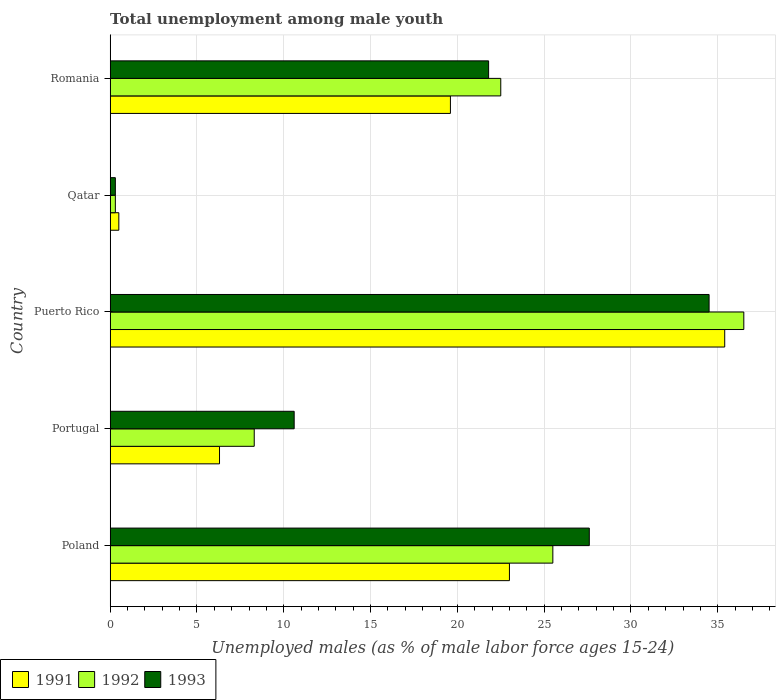How many different coloured bars are there?
Keep it short and to the point. 3. How many groups of bars are there?
Your answer should be compact. 5. Are the number of bars on each tick of the Y-axis equal?
Provide a short and direct response. Yes. What is the label of the 3rd group of bars from the top?
Your answer should be compact. Puerto Rico. In how many cases, is the number of bars for a given country not equal to the number of legend labels?
Make the answer very short. 0. What is the percentage of unemployed males in in 1991 in Puerto Rico?
Make the answer very short. 35.4. Across all countries, what is the maximum percentage of unemployed males in in 1992?
Make the answer very short. 36.5. Across all countries, what is the minimum percentage of unemployed males in in 1993?
Give a very brief answer. 0.3. In which country was the percentage of unemployed males in in 1993 maximum?
Offer a very short reply. Puerto Rico. In which country was the percentage of unemployed males in in 1992 minimum?
Provide a short and direct response. Qatar. What is the total percentage of unemployed males in in 1992 in the graph?
Offer a very short reply. 93.1. What is the difference between the percentage of unemployed males in in 1993 in Portugal and that in Puerto Rico?
Offer a terse response. -23.9. What is the difference between the percentage of unemployed males in in 1992 in Puerto Rico and the percentage of unemployed males in in 1991 in Portugal?
Your answer should be very brief. 30.2. What is the average percentage of unemployed males in in 1992 per country?
Offer a terse response. 18.62. What is the difference between the percentage of unemployed males in in 1993 and percentage of unemployed males in in 1992 in Poland?
Keep it short and to the point. 2.1. What is the ratio of the percentage of unemployed males in in 1993 in Puerto Rico to that in Qatar?
Give a very brief answer. 115. Is the percentage of unemployed males in in 1993 in Portugal less than that in Puerto Rico?
Provide a succinct answer. Yes. What is the difference between the highest and the second highest percentage of unemployed males in in 1991?
Ensure brevity in your answer.  12.4. What is the difference between the highest and the lowest percentage of unemployed males in in 1993?
Your response must be concise. 34.2. What does the 3rd bar from the top in Qatar represents?
Give a very brief answer. 1991. Is it the case that in every country, the sum of the percentage of unemployed males in in 1993 and percentage of unemployed males in in 1991 is greater than the percentage of unemployed males in in 1992?
Your response must be concise. Yes. Are all the bars in the graph horizontal?
Make the answer very short. Yes. What is the difference between two consecutive major ticks on the X-axis?
Offer a very short reply. 5. Are the values on the major ticks of X-axis written in scientific E-notation?
Your response must be concise. No. What is the title of the graph?
Give a very brief answer. Total unemployment among male youth. What is the label or title of the X-axis?
Ensure brevity in your answer.  Unemployed males (as % of male labor force ages 15-24). What is the Unemployed males (as % of male labor force ages 15-24) in 1991 in Poland?
Your answer should be very brief. 23. What is the Unemployed males (as % of male labor force ages 15-24) of 1992 in Poland?
Offer a very short reply. 25.5. What is the Unemployed males (as % of male labor force ages 15-24) in 1993 in Poland?
Provide a succinct answer. 27.6. What is the Unemployed males (as % of male labor force ages 15-24) of 1991 in Portugal?
Make the answer very short. 6.3. What is the Unemployed males (as % of male labor force ages 15-24) of 1992 in Portugal?
Give a very brief answer. 8.3. What is the Unemployed males (as % of male labor force ages 15-24) of 1993 in Portugal?
Your answer should be very brief. 10.6. What is the Unemployed males (as % of male labor force ages 15-24) in 1991 in Puerto Rico?
Offer a terse response. 35.4. What is the Unemployed males (as % of male labor force ages 15-24) in 1992 in Puerto Rico?
Offer a terse response. 36.5. What is the Unemployed males (as % of male labor force ages 15-24) in 1993 in Puerto Rico?
Give a very brief answer. 34.5. What is the Unemployed males (as % of male labor force ages 15-24) of 1991 in Qatar?
Provide a succinct answer. 0.5. What is the Unemployed males (as % of male labor force ages 15-24) of 1992 in Qatar?
Provide a succinct answer. 0.3. What is the Unemployed males (as % of male labor force ages 15-24) in 1993 in Qatar?
Provide a succinct answer. 0.3. What is the Unemployed males (as % of male labor force ages 15-24) in 1991 in Romania?
Make the answer very short. 19.6. What is the Unemployed males (as % of male labor force ages 15-24) in 1993 in Romania?
Provide a short and direct response. 21.8. Across all countries, what is the maximum Unemployed males (as % of male labor force ages 15-24) in 1991?
Your answer should be very brief. 35.4. Across all countries, what is the maximum Unemployed males (as % of male labor force ages 15-24) in 1992?
Offer a terse response. 36.5. Across all countries, what is the maximum Unemployed males (as % of male labor force ages 15-24) of 1993?
Your answer should be compact. 34.5. Across all countries, what is the minimum Unemployed males (as % of male labor force ages 15-24) of 1992?
Give a very brief answer. 0.3. Across all countries, what is the minimum Unemployed males (as % of male labor force ages 15-24) of 1993?
Offer a terse response. 0.3. What is the total Unemployed males (as % of male labor force ages 15-24) of 1991 in the graph?
Make the answer very short. 84.8. What is the total Unemployed males (as % of male labor force ages 15-24) in 1992 in the graph?
Provide a succinct answer. 93.1. What is the total Unemployed males (as % of male labor force ages 15-24) in 1993 in the graph?
Your answer should be very brief. 94.8. What is the difference between the Unemployed males (as % of male labor force ages 15-24) in 1991 in Poland and that in Portugal?
Give a very brief answer. 16.7. What is the difference between the Unemployed males (as % of male labor force ages 15-24) in 1993 in Poland and that in Portugal?
Your answer should be compact. 17. What is the difference between the Unemployed males (as % of male labor force ages 15-24) in 1991 in Poland and that in Puerto Rico?
Provide a succinct answer. -12.4. What is the difference between the Unemployed males (as % of male labor force ages 15-24) of 1993 in Poland and that in Puerto Rico?
Offer a terse response. -6.9. What is the difference between the Unemployed males (as % of male labor force ages 15-24) of 1991 in Poland and that in Qatar?
Your response must be concise. 22.5. What is the difference between the Unemployed males (as % of male labor force ages 15-24) of 1992 in Poland and that in Qatar?
Your response must be concise. 25.2. What is the difference between the Unemployed males (as % of male labor force ages 15-24) in 1993 in Poland and that in Qatar?
Your response must be concise. 27.3. What is the difference between the Unemployed males (as % of male labor force ages 15-24) in 1991 in Poland and that in Romania?
Your answer should be compact. 3.4. What is the difference between the Unemployed males (as % of male labor force ages 15-24) of 1992 in Poland and that in Romania?
Ensure brevity in your answer.  3. What is the difference between the Unemployed males (as % of male labor force ages 15-24) of 1991 in Portugal and that in Puerto Rico?
Ensure brevity in your answer.  -29.1. What is the difference between the Unemployed males (as % of male labor force ages 15-24) in 1992 in Portugal and that in Puerto Rico?
Ensure brevity in your answer.  -28.2. What is the difference between the Unemployed males (as % of male labor force ages 15-24) of 1993 in Portugal and that in Puerto Rico?
Give a very brief answer. -23.9. What is the difference between the Unemployed males (as % of male labor force ages 15-24) in 1991 in Portugal and that in Qatar?
Keep it short and to the point. 5.8. What is the difference between the Unemployed males (as % of male labor force ages 15-24) of 1993 in Portugal and that in Qatar?
Provide a succinct answer. 10.3. What is the difference between the Unemployed males (as % of male labor force ages 15-24) in 1991 in Portugal and that in Romania?
Your response must be concise. -13.3. What is the difference between the Unemployed males (as % of male labor force ages 15-24) of 1992 in Portugal and that in Romania?
Keep it short and to the point. -14.2. What is the difference between the Unemployed males (as % of male labor force ages 15-24) in 1993 in Portugal and that in Romania?
Your answer should be very brief. -11.2. What is the difference between the Unemployed males (as % of male labor force ages 15-24) of 1991 in Puerto Rico and that in Qatar?
Your answer should be compact. 34.9. What is the difference between the Unemployed males (as % of male labor force ages 15-24) of 1992 in Puerto Rico and that in Qatar?
Your answer should be compact. 36.2. What is the difference between the Unemployed males (as % of male labor force ages 15-24) of 1993 in Puerto Rico and that in Qatar?
Your answer should be very brief. 34.2. What is the difference between the Unemployed males (as % of male labor force ages 15-24) of 1991 in Qatar and that in Romania?
Ensure brevity in your answer.  -19.1. What is the difference between the Unemployed males (as % of male labor force ages 15-24) of 1992 in Qatar and that in Romania?
Give a very brief answer. -22.2. What is the difference between the Unemployed males (as % of male labor force ages 15-24) of 1993 in Qatar and that in Romania?
Make the answer very short. -21.5. What is the difference between the Unemployed males (as % of male labor force ages 15-24) in 1991 in Poland and the Unemployed males (as % of male labor force ages 15-24) in 1993 in Portugal?
Provide a short and direct response. 12.4. What is the difference between the Unemployed males (as % of male labor force ages 15-24) of 1991 in Poland and the Unemployed males (as % of male labor force ages 15-24) of 1993 in Puerto Rico?
Your response must be concise. -11.5. What is the difference between the Unemployed males (as % of male labor force ages 15-24) in 1991 in Poland and the Unemployed males (as % of male labor force ages 15-24) in 1992 in Qatar?
Give a very brief answer. 22.7. What is the difference between the Unemployed males (as % of male labor force ages 15-24) of 1991 in Poland and the Unemployed males (as % of male labor force ages 15-24) of 1993 in Qatar?
Your answer should be compact. 22.7. What is the difference between the Unemployed males (as % of male labor force ages 15-24) of 1992 in Poland and the Unemployed males (as % of male labor force ages 15-24) of 1993 in Qatar?
Give a very brief answer. 25.2. What is the difference between the Unemployed males (as % of male labor force ages 15-24) in 1991 in Poland and the Unemployed males (as % of male labor force ages 15-24) in 1993 in Romania?
Ensure brevity in your answer.  1.2. What is the difference between the Unemployed males (as % of male labor force ages 15-24) of 1991 in Portugal and the Unemployed males (as % of male labor force ages 15-24) of 1992 in Puerto Rico?
Offer a very short reply. -30.2. What is the difference between the Unemployed males (as % of male labor force ages 15-24) in 1991 in Portugal and the Unemployed males (as % of male labor force ages 15-24) in 1993 in Puerto Rico?
Provide a short and direct response. -28.2. What is the difference between the Unemployed males (as % of male labor force ages 15-24) in 1992 in Portugal and the Unemployed males (as % of male labor force ages 15-24) in 1993 in Puerto Rico?
Keep it short and to the point. -26.2. What is the difference between the Unemployed males (as % of male labor force ages 15-24) in 1991 in Portugal and the Unemployed males (as % of male labor force ages 15-24) in 1993 in Qatar?
Give a very brief answer. 6. What is the difference between the Unemployed males (as % of male labor force ages 15-24) of 1992 in Portugal and the Unemployed males (as % of male labor force ages 15-24) of 1993 in Qatar?
Offer a terse response. 8. What is the difference between the Unemployed males (as % of male labor force ages 15-24) in 1991 in Portugal and the Unemployed males (as % of male labor force ages 15-24) in 1992 in Romania?
Your answer should be very brief. -16.2. What is the difference between the Unemployed males (as % of male labor force ages 15-24) in 1991 in Portugal and the Unemployed males (as % of male labor force ages 15-24) in 1993 in Romania?
Offer a terse response. -15.5. What is the difference between the Unemployed males (as % of male labor force ages 15-24) of 1992 in Portugal and the Unemployed males (as % of male labor force ages 15-24) of 1993 in Romania?
Keep it short and to the point. -13.5. What is the difference between the Unemployed males (as % of male labor force ages 15-24) of 1991 in Puerto Rico and the Unemployed males (as % of male labor force ages 15-24) of 1992 in Qatar?
Ensure brevity in your answer.  35.1. What is the difference between the Unemployed males (as % of male labor force ages 15-24) of 1991 in Puerto Rico and the Unemployed males (as % of male labor force ages 15-24) of 1993 in Qatar?
Give a very brief answer. 35.1. What is the difference between the Unemployed males (as % of male labor force ages 15-24) in 1992 in Puerto Rico and the Unemployed males (as % of male labor force ages 15-24) in 1993 in Qatar?
Offer a terse response. 36.2. What is the difference between the Unemployed males (as % of male labor force ages 15-24) of 1991 in Puerto Rico and the Unemployed males (as % of male labor force ages 15-24) of 1993 in Romania?
Your response must be concise. 13.6. What is the difference between the Unemployed males (as % of male labor force ages 15-24) in 1991 in Qatar and the Unemployed males (as % of male labor force ages 15-24) in 1993 in Romania?
Ensure brevity in your answer.  -21.3. What is the difference between the Unemployed males (as % of male labor force ages 15-24) in 1992 in Qatar and the Unemployed males (as % of male labor force ages 15-24) in 1993 in Romania?
Keep it short and to the point. -21.5. What is the average Unemployed males (as % of male labor force ages 15-24) of 1991 per country?
Provide a short and direct response. 16.96. What is the average Unemployed males (as % of male labor force ages 15-24) in 1992 per country?
Offer a very short reply. 18.62. What is the average Unemployed males (as % of male labor force ages 15-24) in 1993 per country?
Provide a short and direct response. 18.96. What is the difference between the Unemployed males (as % of male labor force ages 15-24) of 1991 and Unemployed males (as % of male labor force ages 15-24) of 1992 in Poland?
Your answer should be very brief. -2.5. What is the difference between the Unemployed males (as % of male labor force ages 15-24) in 1991 and Unemployed males (as % of male labor force ages 15-24) in 1993 in Poland?
Your answer should be very brief. -4.6. What is the difference between the Unemployed males (as % of male labor force ages 15-24) in 1991 and Unemployed males (as % of male labor force ages 15-24) in 1992 in Portugal?
Give a very brief answer. -2. What is the difference between the Unemployed males (as % of male labor force ages 15-24) of 1991 and Unemployed males (as % of male labor force ages 15-24) of 1993 in Portugal?
Your answer should be very brief. -4.3. What is the difference between the Unemployed males (as % of male labor force ages 15-24) of 1992 and Unemployed males (as % of male labor force ages 15-24) of 1993 in Puerto Rico?
Offer a terse response. 2. What is the difference between the Unemployed males (as % of male labor force ages 15-24) in 1991 and Unemployed males (as % of male labor force ages 15-24) in 1992 in Qatar?
Offer a very short reply. 0.2. What is the difference between the Unemployed males (as % of male labor force ages 15-24) of 1991 and Unemployed males (as % of male labor force ages 15-24) of 1993 in Romania?
Make the answer very short. -2.2. What is the ratio of the Unemployed males (as % of male labor force ages 15-24) of 1991 in Poland to that in Portugal?
Ensure brevity in your answer.  3.65. What is the ratio of the Unemployed males (as % of male labor force ages 15-24) of 1992 in Poland to that in Portugal?
Offer a terse response. 3.07. What is the ratio of the Unemployed males (as % of male labor force ages 15-24) in 1993 in Poland to that in Portugal?
Your response must be concise. 2.6. What is the ratio of the Unemployed males (as % of male labor force ages 15-24) in 1991 in Poland to that in Puerto Rico?
Offer a terse response. 0.65. What is the ratio of the Unemployed males (as % of male labor force ages 15-24) of 1992 in Poland to that in Puerto Rico?
Your response must be concise. 0.7. What is the ratio of the Unemployed males (as % of male labor force ages 15-24) in 1991 in Poland to that in Qatar?
Make the answer very short. 46. What is the ratio of the Unemployed males (as % of male labor force ages 15-24) in 1992 in Poland to that in Qatar?
Ensure brevity in your answer.  85. What is the ratio of the Unemployed males (as % of male labor force ages 15-24) of 1993 in Poland to that in Qatar?
Make the answer very short. 92. What is the ratio of the Unemployed males (as % of male labor force ages 15-24) in 1991 in Poland to that in Romania?
Ensure brevity in your answer.  1.17. What is the ratio of the Unemployed males (as % of male labor force ages 15-24) of 1992 in Poland to that in Romania?
Offer a very short reply. 1.13. What is the ratio of the Unemployed males (as % of male labor force ages 15-24) in 1993 in Poland to that in Romania?
Give a very brief answer. 1.27. What is the ratio of the Unemployed males (as % of male labor force ages 15-24) in 1991 in Portugal to that in Puerto Rico?
Provide a succinct answer. 0.18. What is the ratio of the Unemployed males (as % of male labor force ages 15-24) in 1992 in Portugal to that in Puerto Rico?
Provide a succinct answer. 0.23. What is the ratio of the Unemployed males (as % of male labor force ages 15-24) in 1993 in Portugal to that in Puerto Rico?
Ensure brevity in your answer.  0.31. What is the ratio of the Unemployed males (as % of male labor force ages 15-24) of 1992 in Portugal to that in Qatar?
Make the answer very short. 27.67. What is the ratio of the Unemployed males (as % of male labor force ages 15-24) of 1993 in Portugal to that in Qatar?
Provide a short and direct response. 35.33. What is the ratio of the Unemployed males (as % of male labor force ages 15-24) in 1991 in Portugal to that in Romania?
Your response must be concise. 0.32. What is the ratio of the Unemployed males (as % of male labor force ages 15-24) of 1992 in Portugal to that in Romania?
Your response must be concise. 0.37. What is the ratio of the Unemployed males (as % of male labor force ages 15-24) of 1993 in Portugal to that in Romania?
Make the answer very short. 0.49. What is the ratio of the Unemployed males (as % of male labor force ages 15-24) of 1991 in Puerto Rico to that in Qatar?
Offer a very short reply. 70.8. What is the ratio of the Unemployed males (as % of male labor force ages 15-24) in 1992 in Puerto Rico to that in Qatar?
Give a very brief answer. 121.67. What is the ratio of the Unemployed males (as % of male labor force ages 15-24) in 1993 in Puerto Rico to that in Qatar?
Give a very brief answer. 115. What is the ratio of the Unemployed males (as % of male labor force ages 15-24) of 1991 in Puerto Rico to that in Romania?
Your response must be concise. 1.81. What is the ratio of the Unemployed males (as % of male labor force ages 15-24) in 1992 in Puerto Rico to that in Romania?
Your answer should be very brief. 1.62. What is the ratio of the Unemployed males (as % of male labor force ages 15-24) in 1993 in Puerto Rico to that in Romania?
Provide a short and direct response. 1.58. What is the ratio of the Unemployed males (as % of male labor force ages 15-24) of 1991 in Qatar to that in Romania?
Make the answer very short. 0.03. What is the ratio of the Unemployed males (as % of male labor force ages 15-24) in 1992 in Qatar to that in Romania?
Your answer should be very brief. 0.01. What is the ratio of the Unemployed males (as % of male labor force ages 15-24) of 1993 in Qatar to that in Romania?
Give a very brief answer. 0.01. What is the difference between the highest and the second highest Unemployed males (as % of male labor force ages 15-24) in 1991?
Give a very brief answer. 12.4. What is the difference between the highest and the second highest Unemployed males (as % of male labor force ages 15-24) in 1992?
Your answer should be compact. 11. What is the difference between the highest and the second highest Unemployed males (as % of male labor force ages 15-24) of 1993?
Ensure brevity in your answer.  6.9. What is the difference between the highest and the lowest Unemployed males (as % of male labor force ages 15-24) of 1991?
Ensure brevity in your answer.  34.9. What is the difference between the highest and the lowest Unemployed males (as % of male labor force ages 15-24) in 1992?
Provide a succinct answer. 36.2. What is the difference between the highest and the lowest Unemployed males (as % of male labor force ages 15-24) of 1993?
Provide a short and direct response. 34.2. 